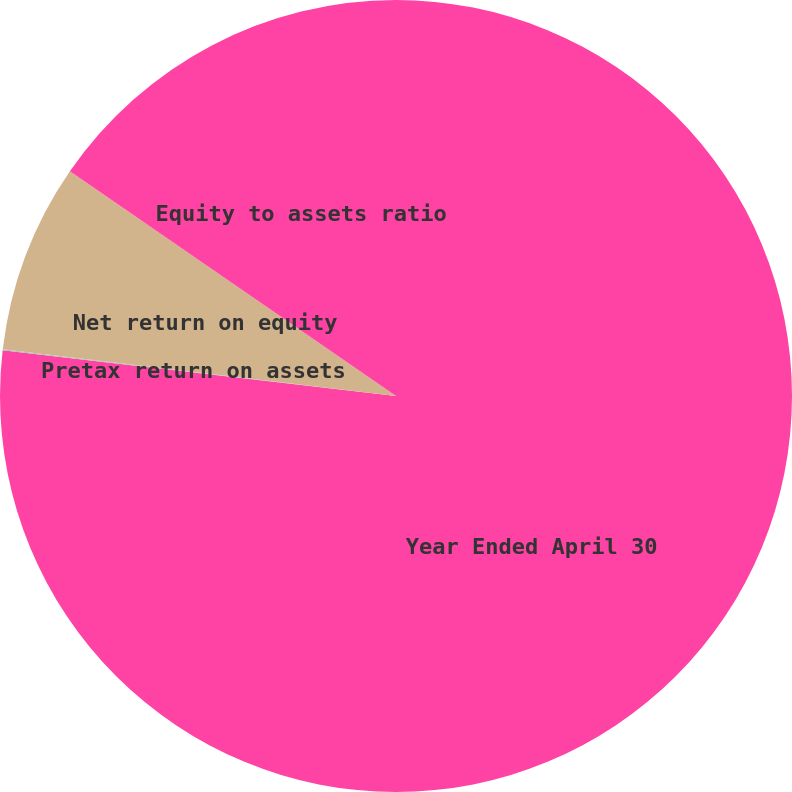<chart> <loc_0><loc_0><loc_500><loc_500><pie_chart><fcel>Year Ended April 30<fcel>Pretax return on assets<fcel>Net return on equity<fcel>Equity to assets ratio<nl><fcel>76.84%<fcel>0.04%<fcel>7.72%<fcel>15.4%<nl></chart> 